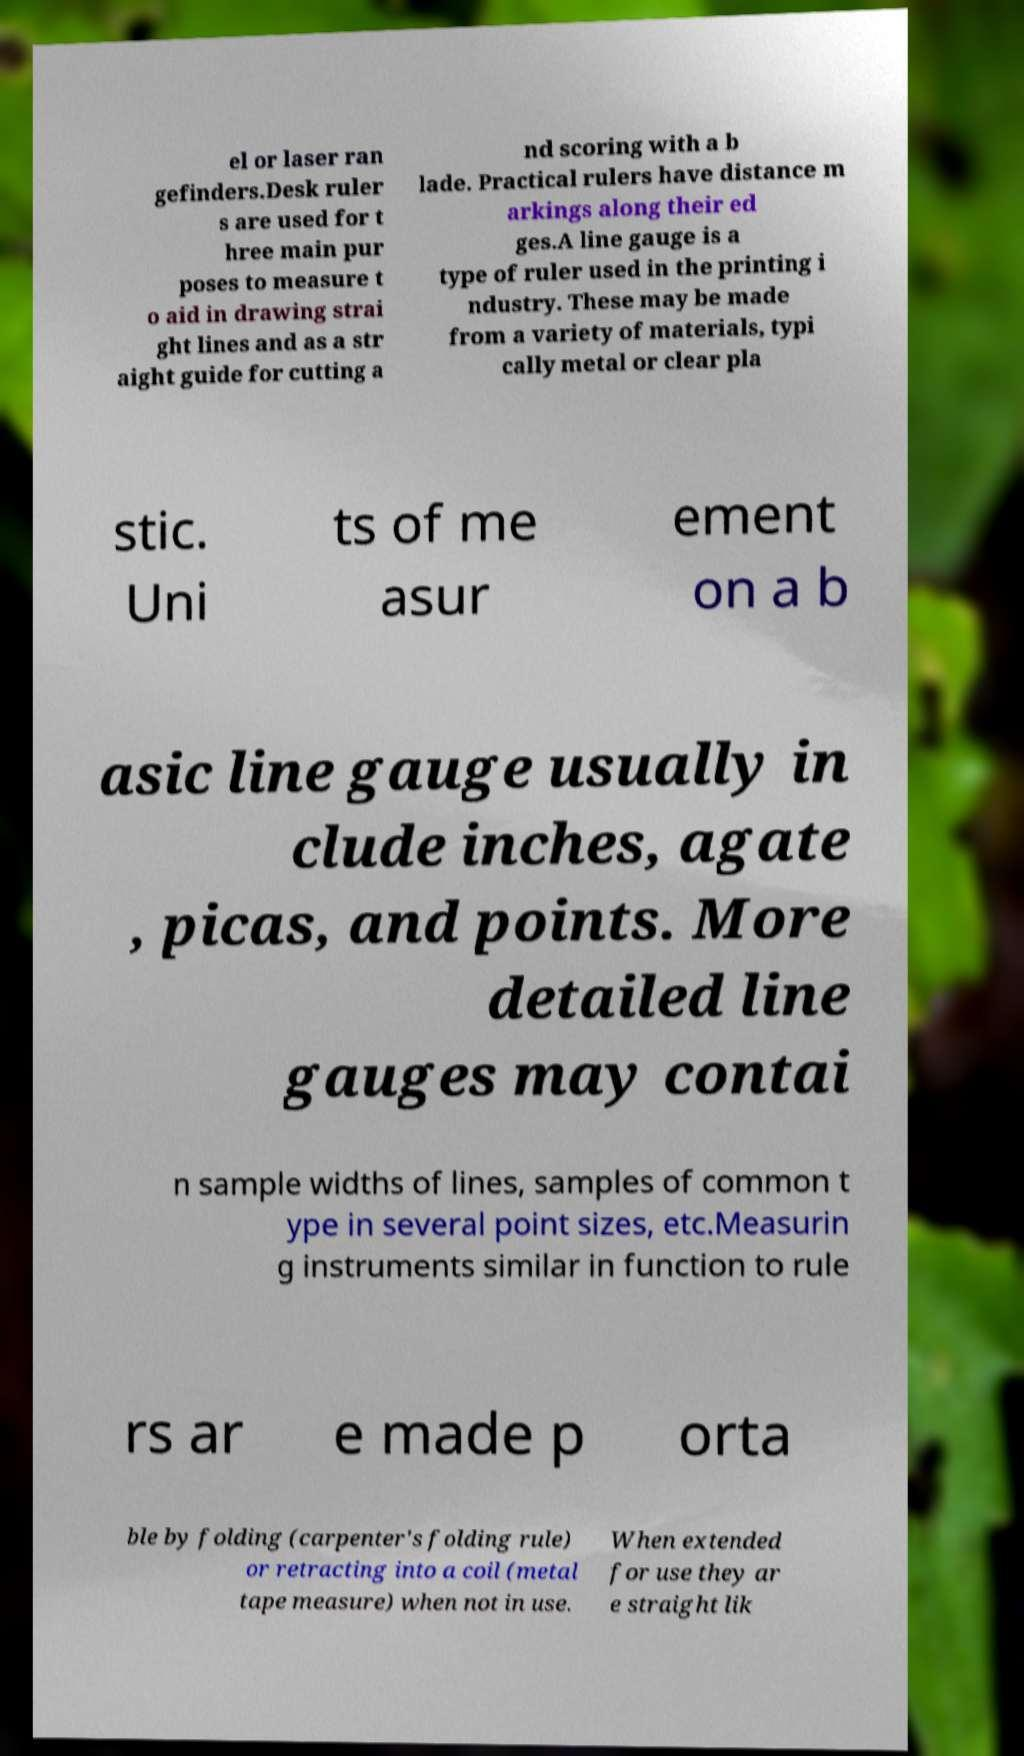Please identify and transcribe the text found in this image. el or laser ran gefinders.Desk ruler s are used for t hree main pur poses to measure t o aid in drawing strai ght lines and as a str aight guide for cutting a nd scoring with a b lade. Practical rulers have distance m arkings along their ed ges.A line gauge is a type of ruler used in the printing i ndustry. These may be made from a variety of materials, typi cally metal or clear pla stic. Uni ts of me asur ement on a b asic line gauge usually in clude inches, agate , picas, and points. More detailed line gauges may contai n sample widths of lines, samples of common t ype in several point sizes, etc.Measurin g instruments similar in function to rule rs ar e made p orta ble by folding (carpenter's folding rule) or retracting into a coil (metal tape measure) when not in use. When extended for use they ar e straight lik 